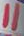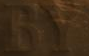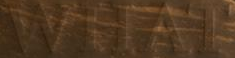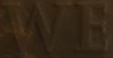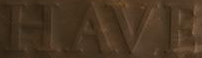Transcribe the words shown in these images in order, separated by a semicolon. "; BY; WHAT; WE; HAVE 